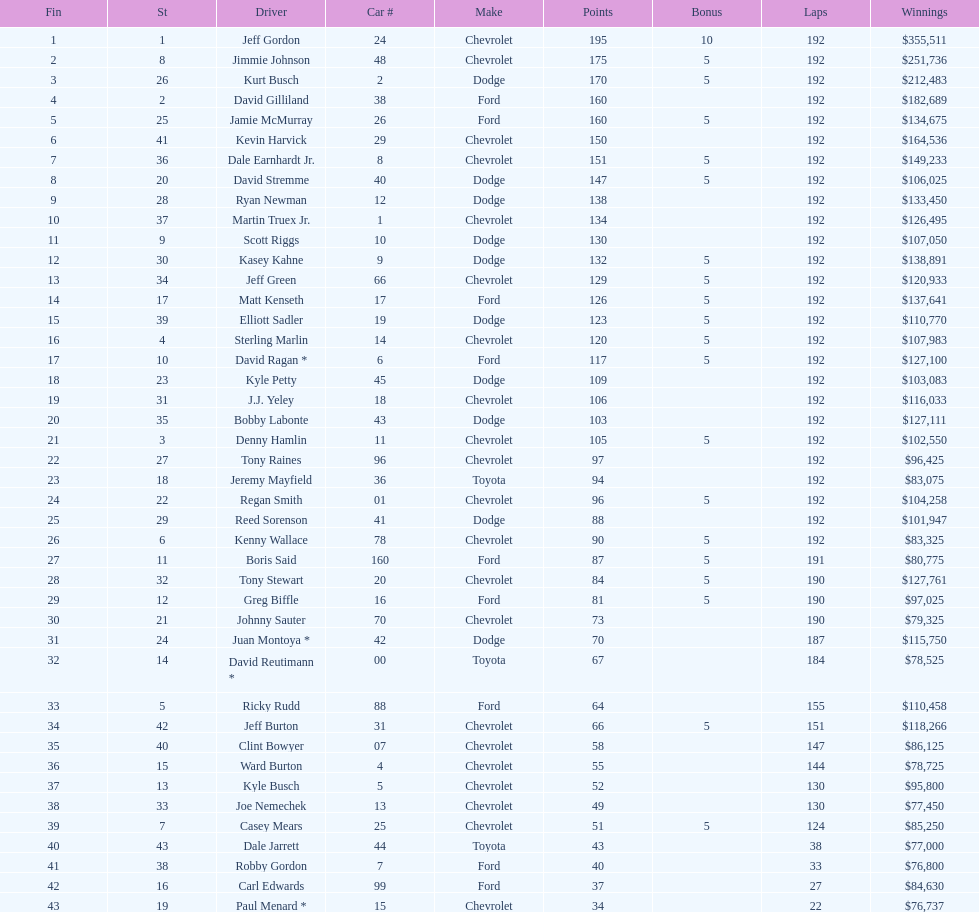What make did kurt busch drive? Dodge. 